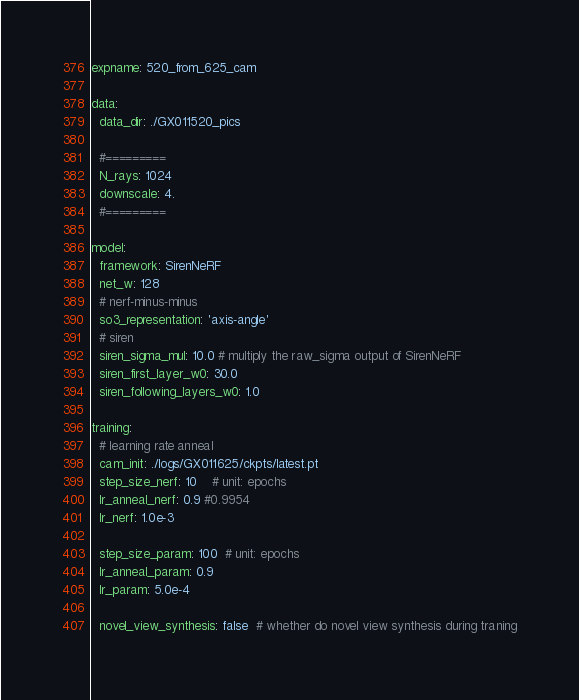<code> <loc_0><loc_0><loc_500><loc_500><_YAML_>expname: 520_from_625_cam

data:
  data_dir: ./GX011520_pics

  #=========
  N_rays: 1024
  downscale: 4.
  #=========

model:
  framework: SirenNeRF
  net_w: 128
  # nerf-minus-minus
  so3_representation: 'axis-angle'
  # siren
  siren_sigma_mul: 10.0 # multiply the raw_sigma output of SirenNeRF
  siren_first_layer_w0: 30.0
  siren_following_layers_w0: 1.0

training:
  # learning rate anneal
  cam_init: ./logs/GX011625/ckpts/latest.pt
  step_size_nerf: 10    # unit: epochs
  lr_anneal_nerf: 0.9 #0.9954
  lr_nerf: 1.0e-3

  step_size_param: 100  # unit: epochs
  lr_anneal_param: 0.9
  lr_param: 5.0e-4

  novel_view_synthesis: false  # whether do novel view synthesis during traning</code> 